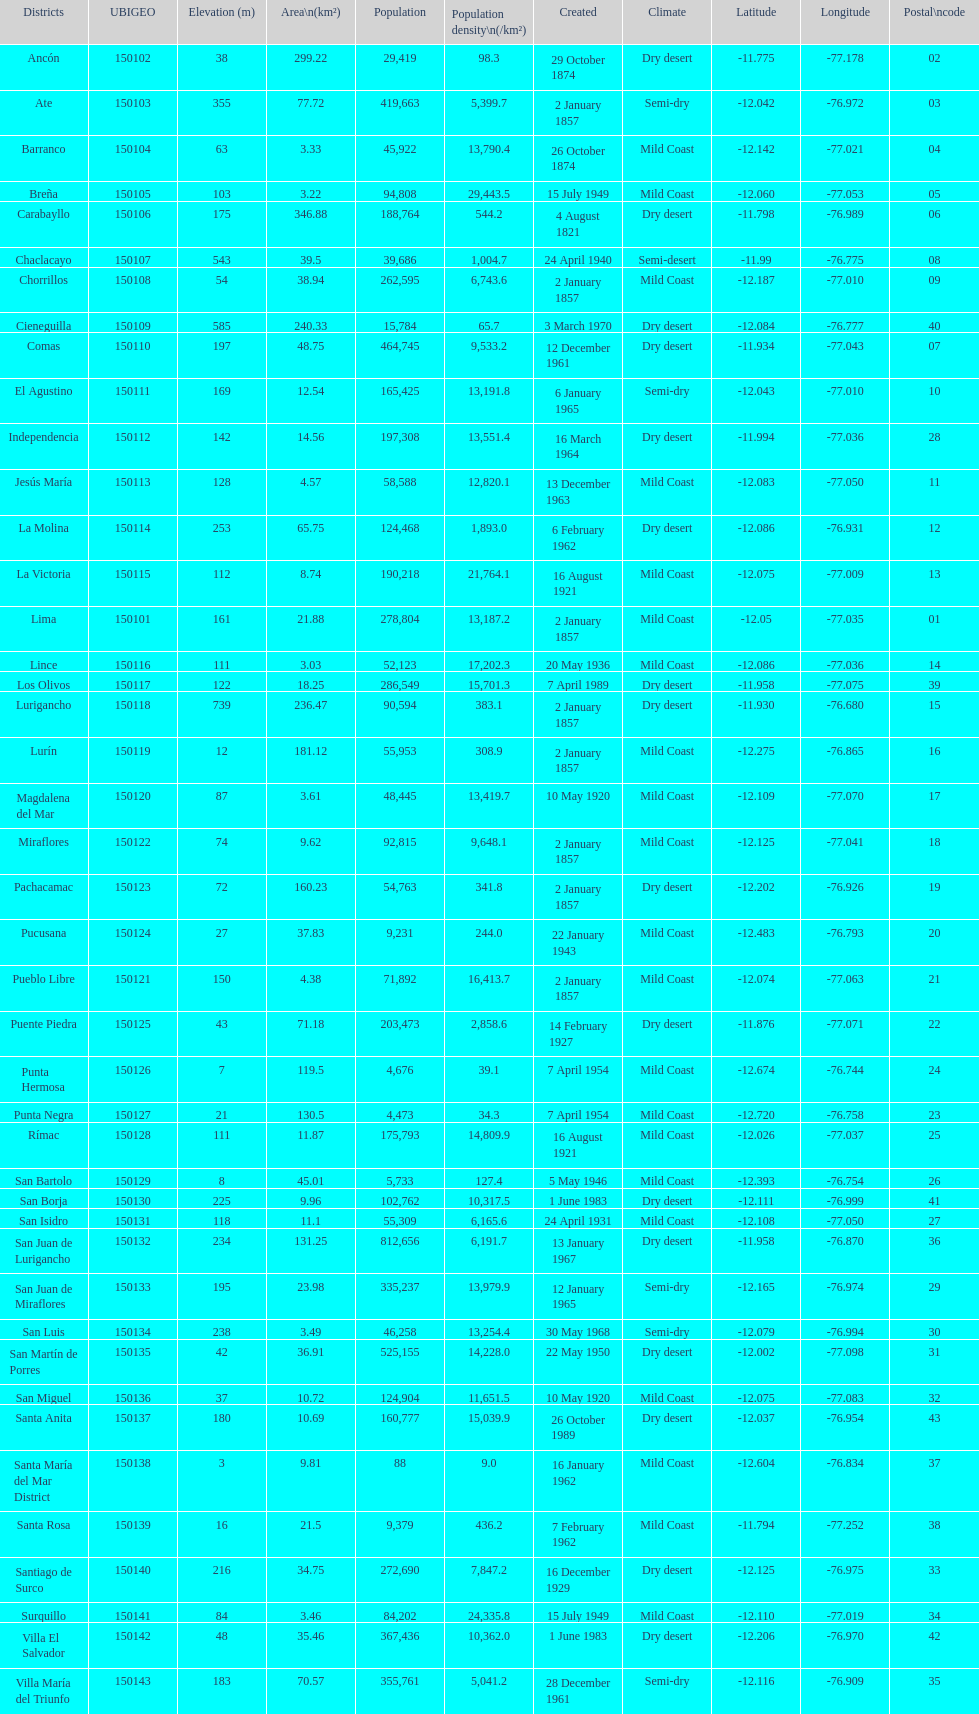Which is the largest district in terms of population? San Juan de Lurigancho. 